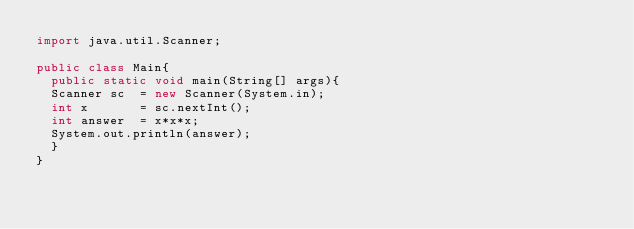Convert code to text. <code><loc_0><loc_0><loc_500><loc_500><_Java_>import java.util.Scanner;

public class Main{
  public static void main(String[] args){
  Scanner sc  = new Scanner(System.in);
  int x       = sc.nextInt();
  int answer  = x*x*x;
  System.out.println(answer);
  }
}

</code> 